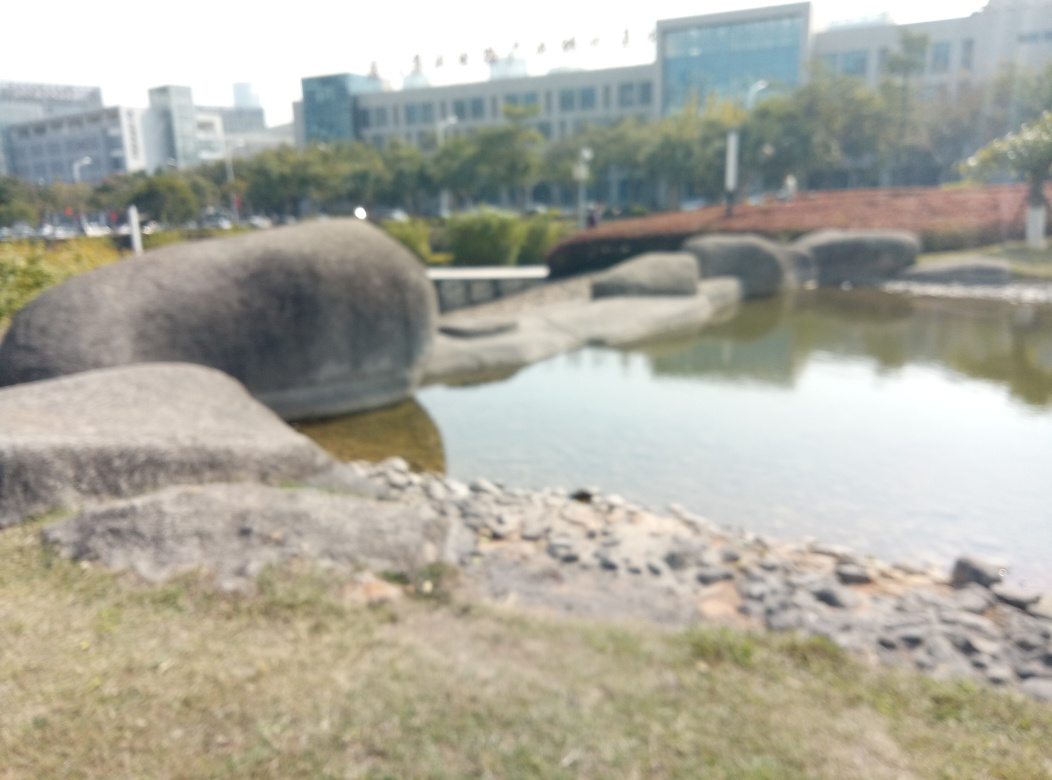What are the main subjects in this image? A. People and animals B. The lawn, rocks, and lake surface C. Sky and clouds D. Buildings, cars, and roads Answer with the option's letter from the given choices directly. Upon reviewing the image, it is clear that the focus is primarily on the outdoor landscape elements, particularly the lawn, rocks, and the surface of the lake. Therefore, option B is the most accurate response. The image features no visible people, animals, buildings, cars, or roads, and although the sky is present, it is not the main subject. The visible rocks and calm water body offer a sense of stillness and tranquility, which dominates the foreground of the photograph, and the soft grassy area adds to the natural setting. The image, taken with a shallow depth of field, appears slightly blurred, adding a artistic impression, which draws the viewer's attention towards the textures and elements at the forefront. 